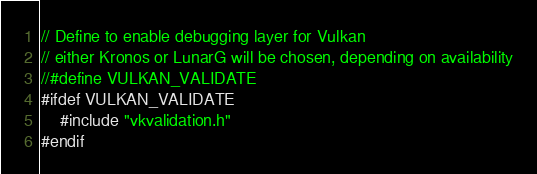Convert code to text. <code><loc_0><loc_0><loc_500><loc_500><_C_>// Define to enable debugging layer for Vulkan
// either Kronos or LunarG will be chosen, depending on availability
//#define VULKAN_VALIDATE
#ifdef VULKAN_VALIDATE
    #include "vkvalidation.h"
#endif
</code> 